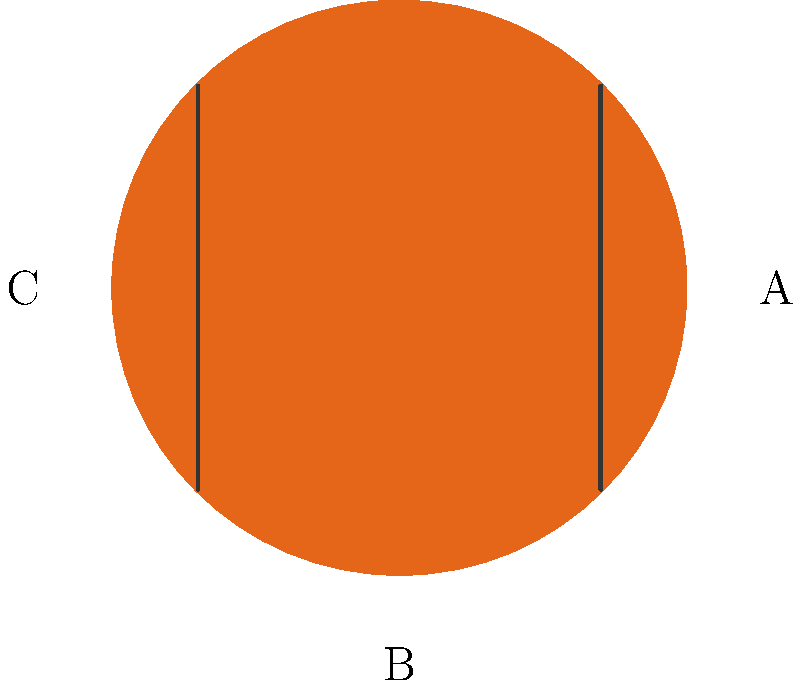As a community sports leader, you're demonstrating the concept of mental rotation to young athletes. The image shows three basketballs with markings in different orientations. Which of the basketballs (A, B, or C) would match the orientation of ball A if rotated 240° clockwise? To solve this problem, we need to follow these steps:

1. Understand the initial orientation of ball A.
2. Visualize a 240° clockwise rotation.
3. Compare the result with the other balls.

Step 1: Ball A has two parallel lines running from top-left to bottom-right.

Step 2: A 240° clockwise rotation is equivalent to a 120° counterclockwise rotation (360° - 240° = 120°). Mentally rotate ball A by 120° counterclockwise.

Step 3: After the rotation:
- The lines would now run from top-right to bottom-left.
- This new orientation matches the orientation of ball C.

Therefore, if ball A is rotated 240° clockwise (or 120° counterclockwise), it would match the orientation of ball C.
Answer: C 